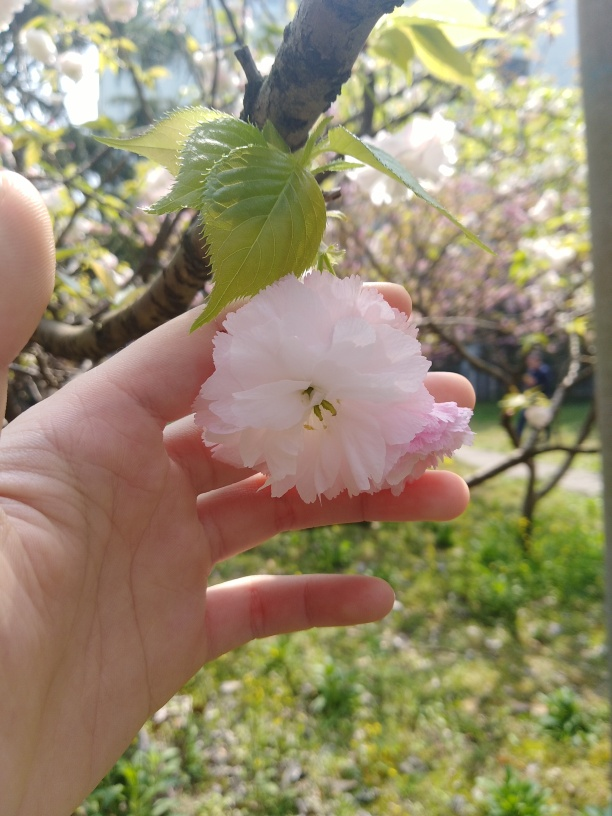What time of year does this photo seem to be taken? Given the blooming cherry blossom, this photo was likely taken in spring. This is when cherry trees flower, offering a brief but stunning display that is often treasured and celebrated in many cultures, particularly in Japan. How can you determine the photo was taken during the day? The natural light and the visibility of shadows on the fingers holding the blossom suggest that the photo was taken during daylight hours. The lighting has a warm, soft quality, indicative of a sunny day, possibly morning or late afternoon, when the sun is not directly overhead. 